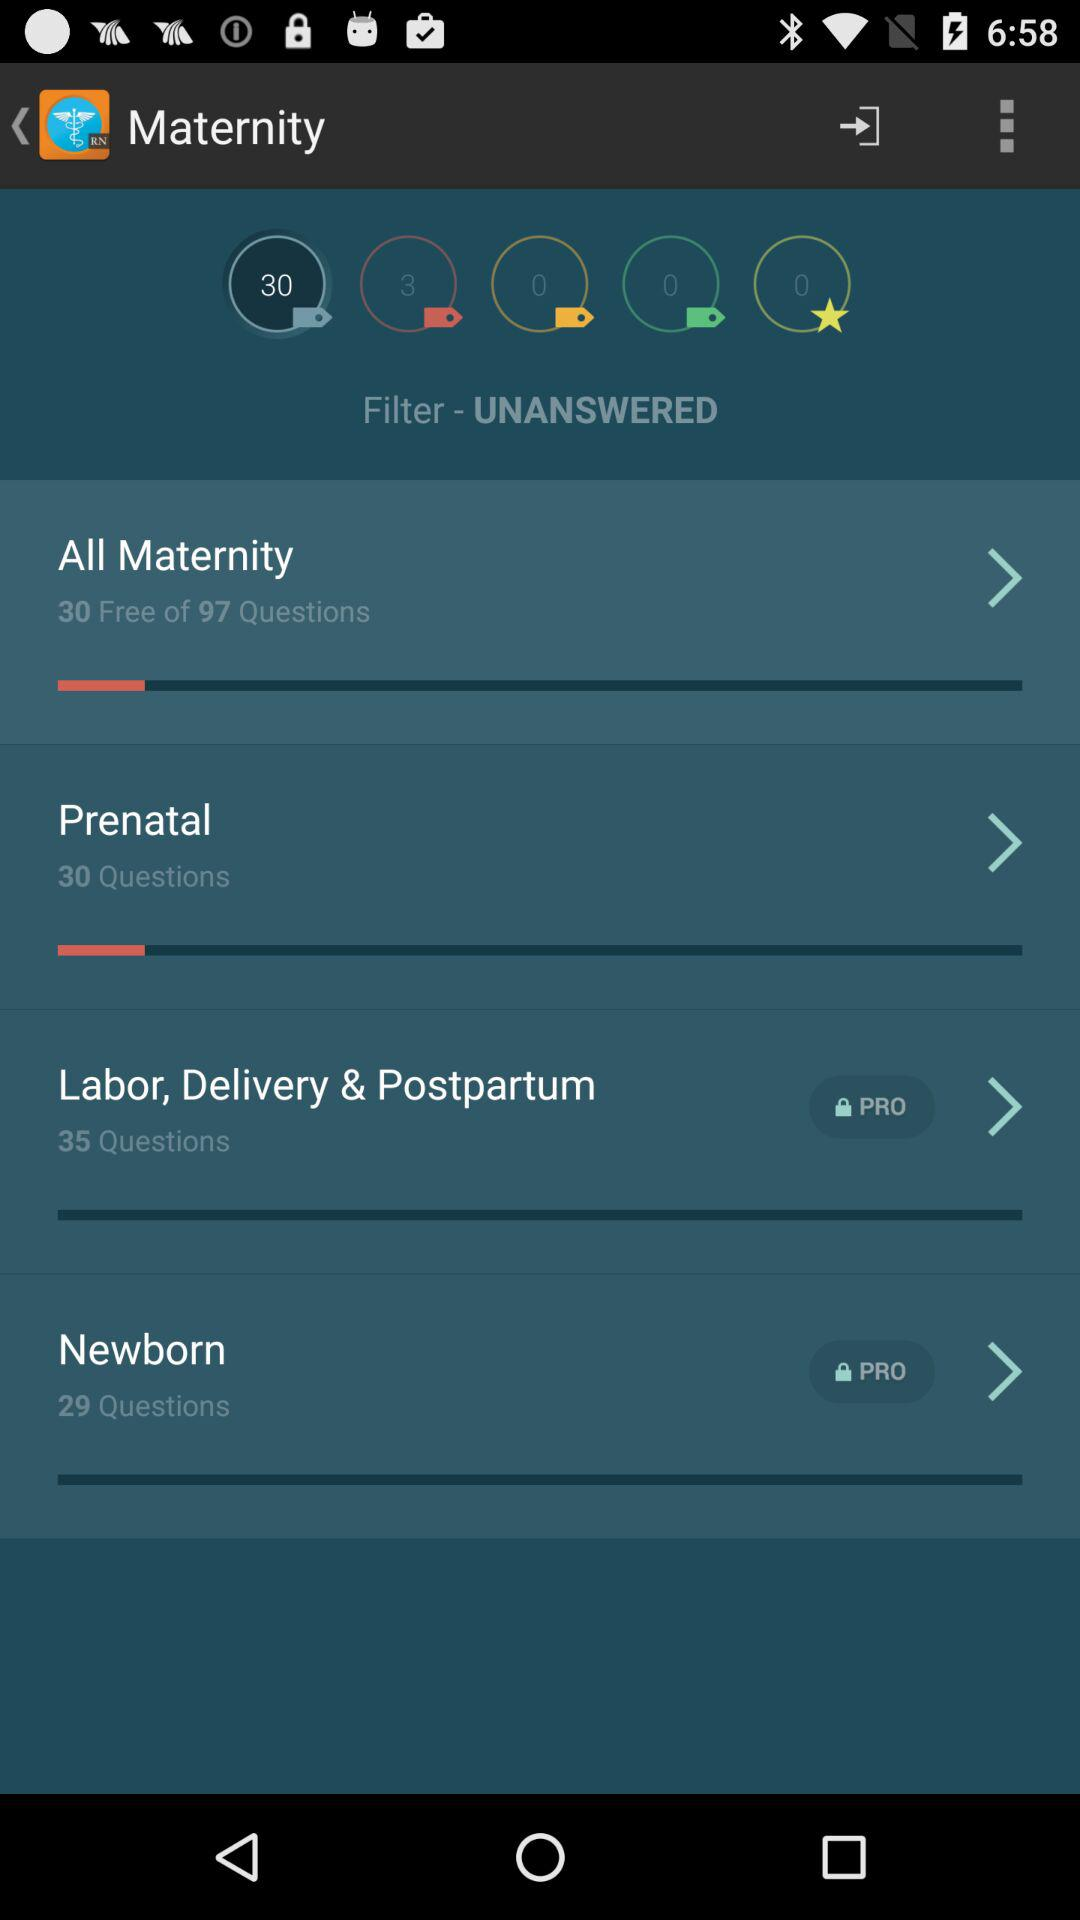How many questions are in the All Maternity section that are not free?
Answer the question using a single word or phrase. 67 